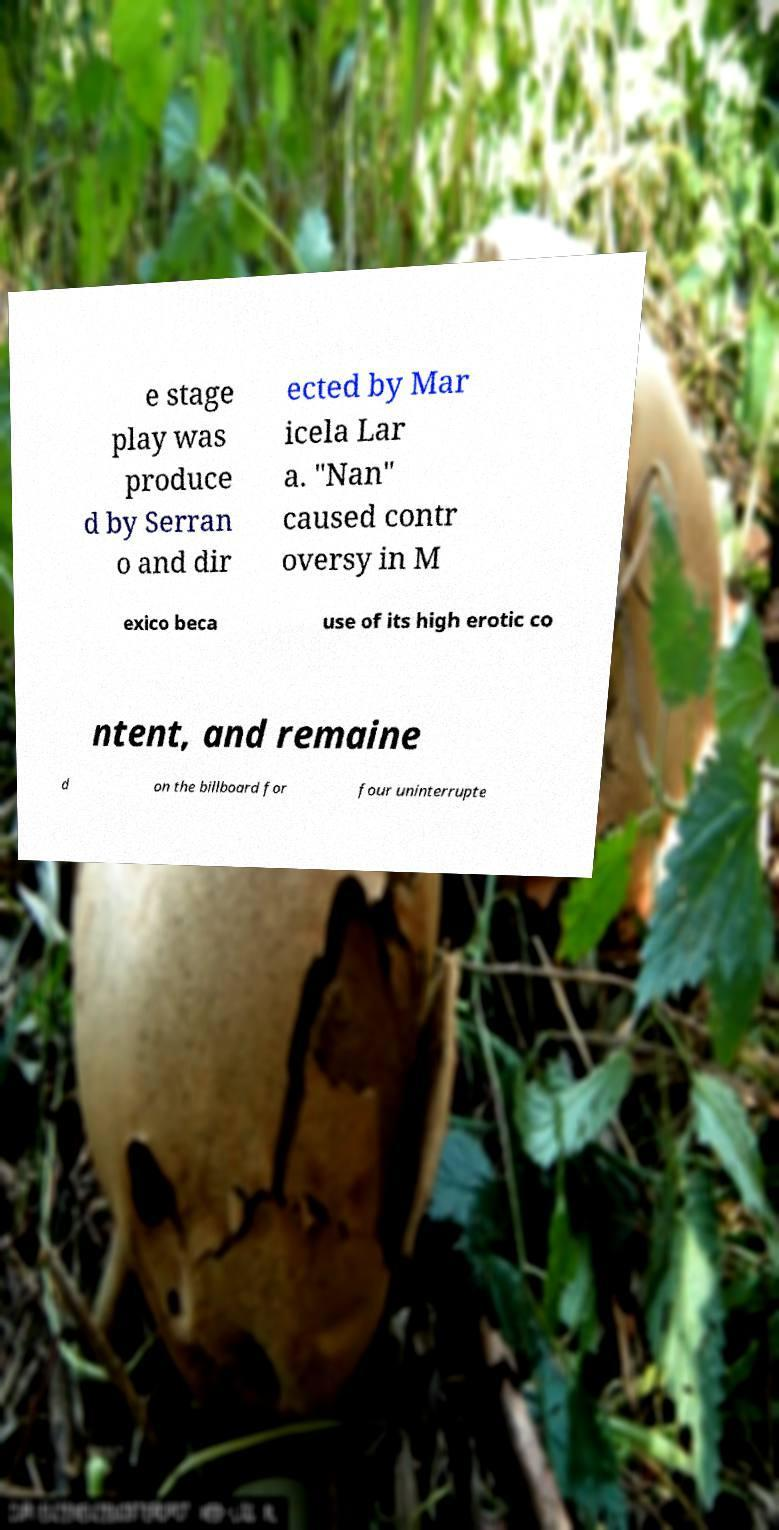Can you read and provide the text displayed in the image?This photo seems to have some interesting text. Can you extract and type it out for me? e stage play was produce d by Serran o and dir ected by Mar icela Lar a. "Nan" caused contr oversy in M exico beca use of its high erotic co ntent, and remaine d on the billboard for four uninterrupte 